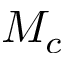<formula> <loc_0><loc_0><loc_500><loc_500>M _ { c }</formula> 